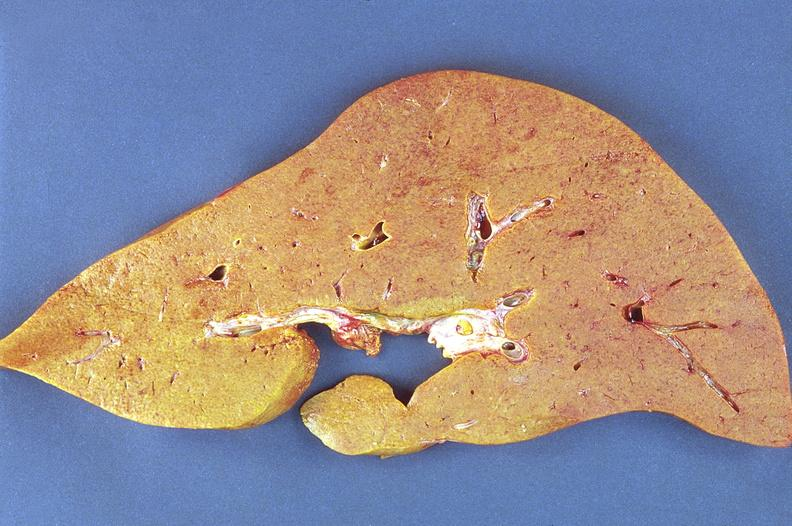s malignant adenoma present?
Answer the question using a single word or phrase. No 